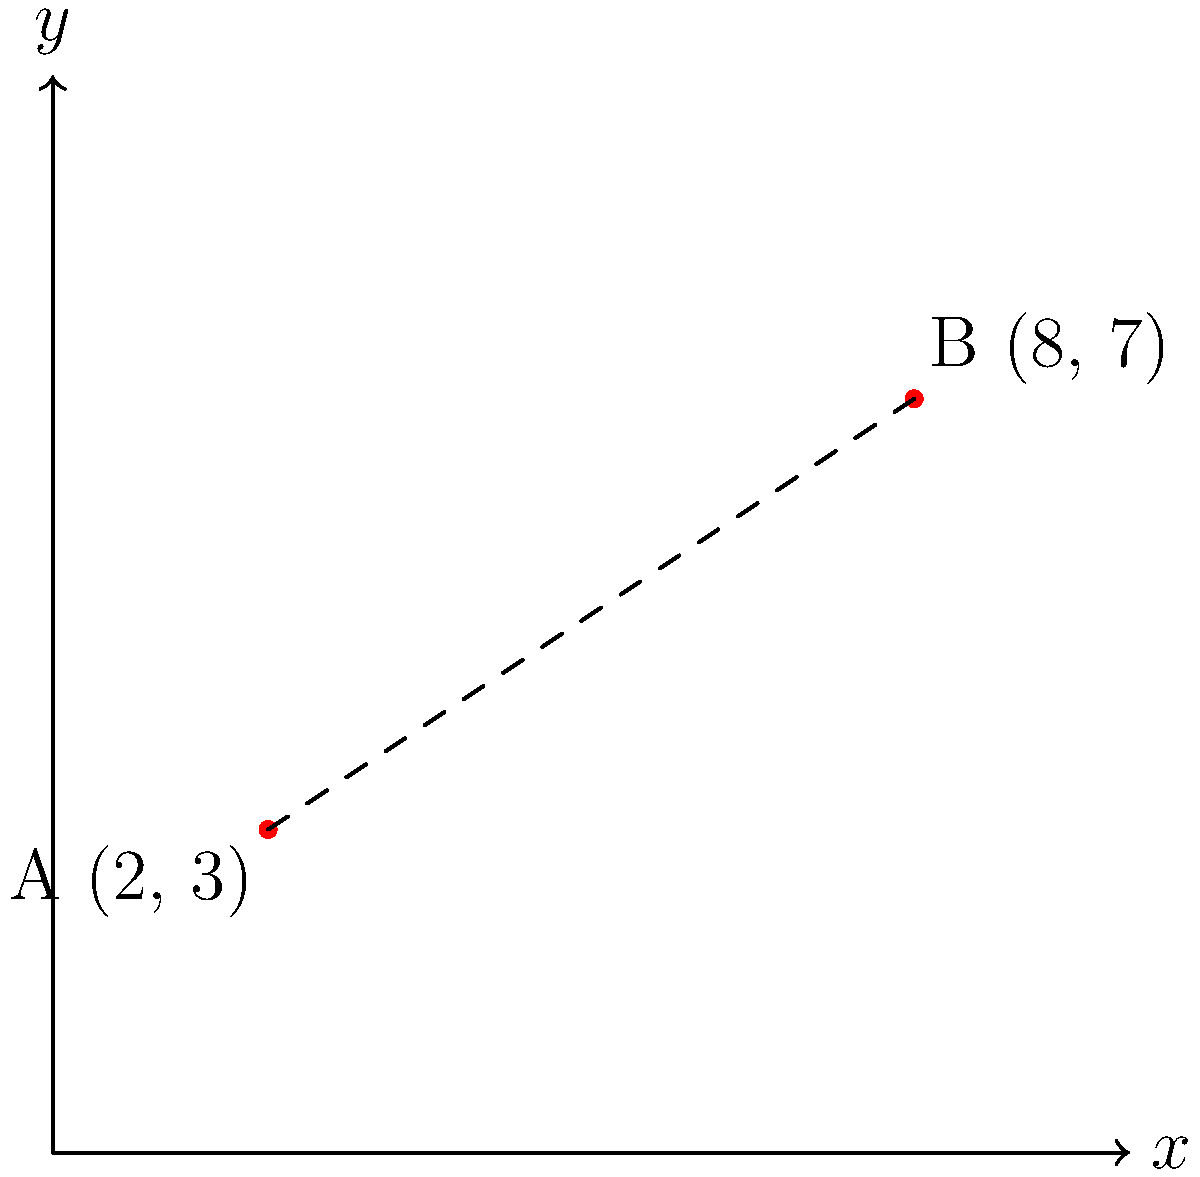During the 2021 South African municipal elections, two voting centers in Johannesburg were located at coordinates A(2, 3) and B(8, 7) on a city map grid. As a volunteer for the African National Congress, you need to calculate the straight-line distance between these two voting centers. What is the distance between points A and B in grid units? To find the distance between two points on a coordinate plane, we can use the distance formula, which is derived from the Pythagorean theorem:

$$d = \sqrt{(x_2 - x_1)^2 + (y_2 - y_1)^2}$$

Where $(x_1, y_1)$ are the coordinates of the first point and $(x_2, y_2)$ are the coordinates of the second point.

Given:
Point A: $(x_1, y_1) = (2, 3)$
Point B: $(x_2, y_2) = (8, 7)$

Let's solve this step-by-step:

1) Substitute the values into the distance formula:
   $$d = \sqrt{(8 - 2)^2 + (7 - 3)^2}$$

2) Simplify the expressions inside the parentheses:
   $$d = \sqrt{6^2 + 4^2}$$

3) Calculate the squares:
   $$d = \sqrt{36 + 16}$$

4) Add the numbers under the square root:
   $$d = \sqrt{52}$$

5) Simplify the square root:
   $$d = 2\sqrt{13}$$

Therefore, the distance between the two voting centers is $2\sqrt{13}$ grid units.
Answer: $2\sqrt{13}$ grid units 